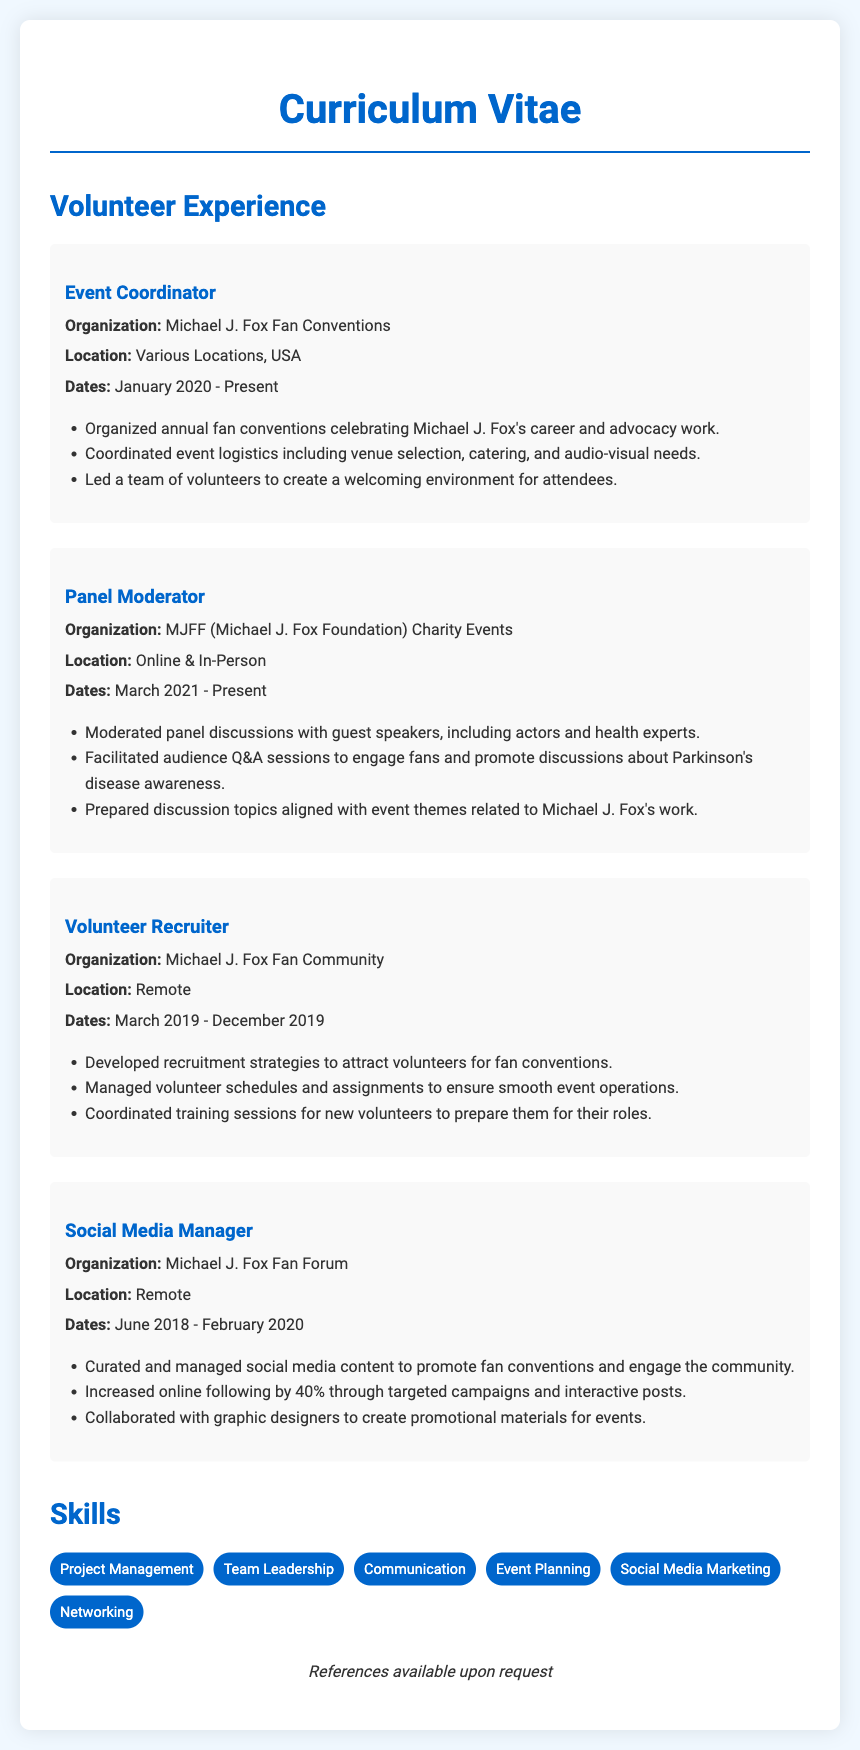What is the title of this document? The title of the document is indicated prominently at the top as "Curriculum Vitae."
Answer: Curriculum Vitae Who is the main subject of this CV? The CV reflects experiences related to a fan community that celebrates Michael J. Fox.
Answer: Michael J. Fox How long has the Event Coordinator experience lasted as of now? The Event Coordinator experience started in January 2020 and is currently ongoing, indicating it has lasted for a specific duration.
Answer: 3 years In which organization did the panel moderation occur? The organization mentioned for panel moderation is the "MJFF (Michael J. Fox Foundation) Charity Events."
Answer: MJFF What role did the individual have between March 2019 and December 2019? The role listed during that timeframe was "Volunteer Recruiter."
Answer: Volunteer Recruiter How much did the online following increase while managing social media? The document states that the online following increased by a percentage indicated during social media management.
Answer: 40% What skills are mentioned in the CV? The CV lists a variety of skills relevant to the subject's experiences.
Answer: Project Management, Team Leadership, Communication, Event Planning, Social Media Marketing, Networking How many volunteer roles are listed in the experience section? The experience section outlines distinct roles held by the individual, counting the various positions.
Answer: 4 What is a specific focus of the panel discussions moderated? The discussions moderated focused on a particular theme related to health and advocacy efforts associated with the main subject.
Answer: Parkinson's disease awareness 